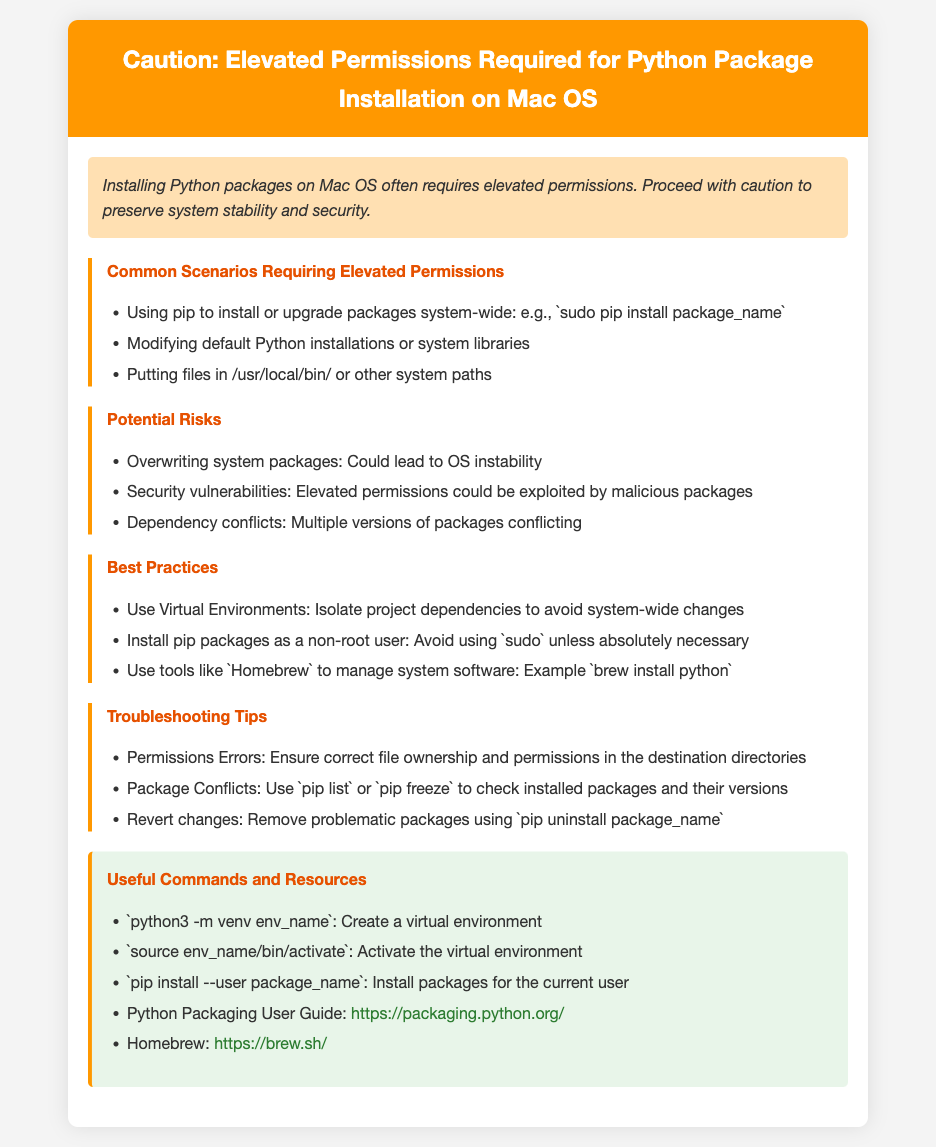What is the warning about? The warning states that installing Python packages on Mac OS often requires elevated permissions, highlighting the need to proceed with caution.
Answer: Elevated permissions required for Python package installation What is an example of a command that requires elevated permissions? The document provides an example of using pip to install packages system-wide with the command `sudo pip install package_name`.
Answer: sudo pip install package_name What is one potential risk mentioned in the document? The document lists multiple potential risks, one of which is overwriting system packages, which could lead to OS instability.
Answer: Overwriting system packages What should you do to isolate project dependencies? The best practice mentioned for isolating project dependencies is to use virtual environments.
Answer: Use Virtual Environments What command creates a virtual environment? The document includes the command `python3 -m venv env_name` for creating a virtual environment.
Answer: python3 -m venv env_name Which resource is suggested for managing system software? Among the best practices outlined, it suggests using tools like Homebrew to manage system software.
Answer: Homebrew What is a recommended method to avoid using sudo? The document advises installing pip packages as a non-root user to avoid using sudo unless absolutely necessary.
Answer: Install pip packages as a non-root user What action can you take if you encounter permissions errors? The document recommends ensuring correct file ownership and permissions in the destination directories if you have permissions errors.
Answer: Ensure correct file ownership and permissions What is a useful resource provided for Python packaging? The document lists the Python Packaging User Guide as a useful resource, with a provided URL.
Answer: Python Packaging User Guide 